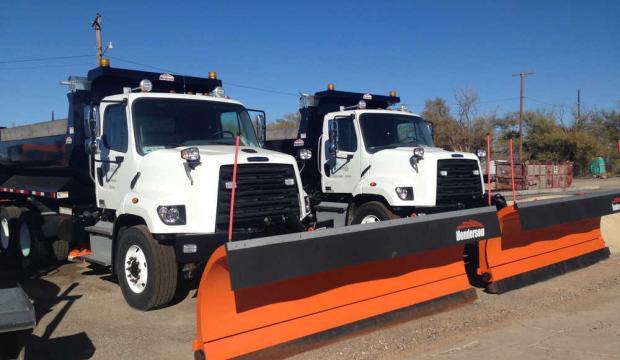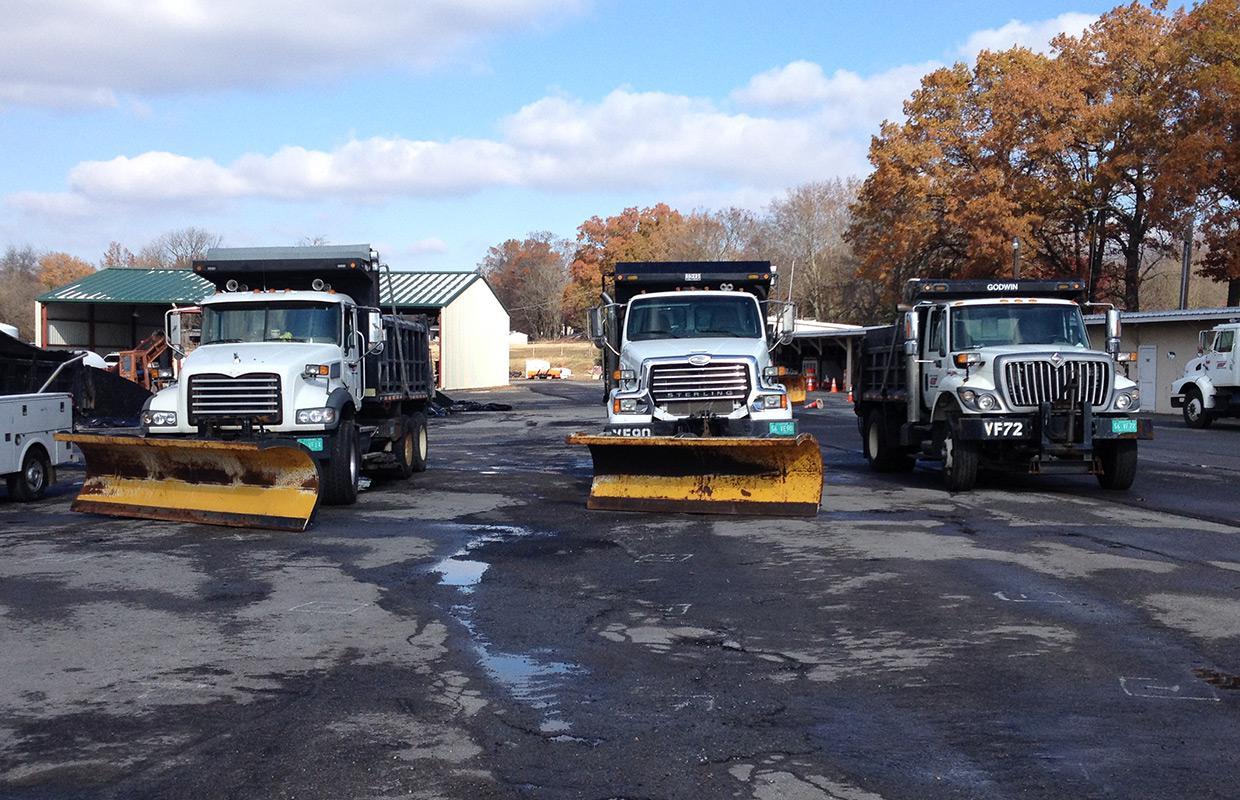The first image is the image on the left, the second image is the image on the right. Examine the images to the left and right. Is the description "There is one snow plow in the image on the right." accurate? Answer yes or no. No. The first image is the image on the left, the second image is the image on the right. Assess this claim about the two images: "An image includes a truck with an orange plow and a white cab.". Correct or not? Answer yes or no. Yes. 